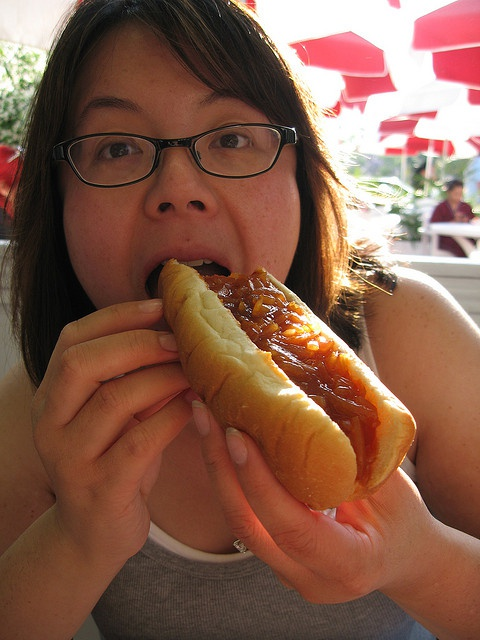Describe the objects in this image and their specific colors. I can see people in maroon, white, brown, and black tones, hot dog in white, brown, maroon, and tan tones, umbrella in white, salmon, red, and lightpink tones, umbrella in white, salmon, and lightpink tones, and umbrella in white, salmon, and lightpink tones in this image. 